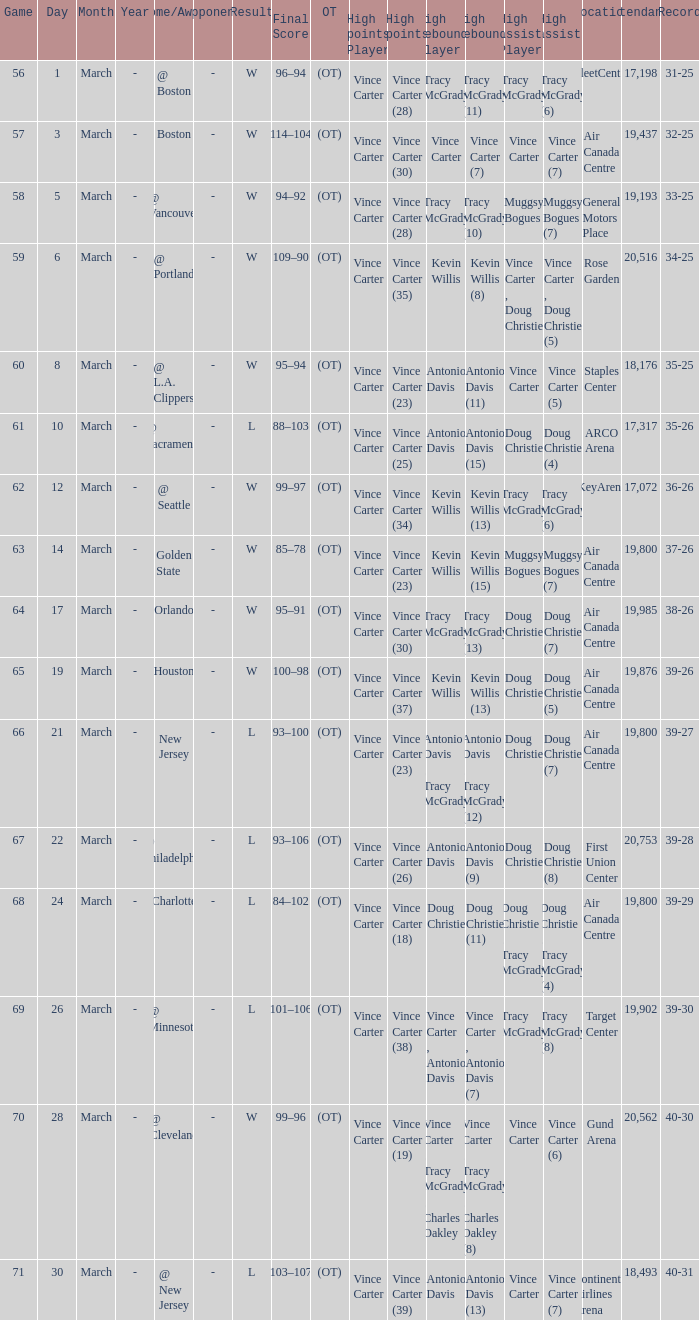Parse the table in full. {'header': ['Game', 'Day', 'Month', 'Year', 'Home/Away', 'Opponent', 'Result', 'Final Score', 'OT', 'High points Player', 'High points', 'High rebounds Player', 'High rebounds', 'High assists Player', 'High assists', 'Location', 'Attendance', 'Record'], 'rows': [['56', '1', 'March', '-', '@ Boston', '-', 'W', '96–94', '(OT)', 'Vince Carter', 'Vince Carter (28)', 'Tracy McGrady', 'Tracy McGrady (11)', 'Tracy McGrady', 'Tracy McGrady (6)', 'FleetCenter', '17,198', '31-25'], ['57', '3', 'March', '-', 'Boston', '-', 'W', '114–104', '(OT)', 'Vince Carter', 'Vince Carter (30)', 'Vince Carter', 'Vince Carter (7)', 'Vince Carter', 'Vince Carter (7)', 'Air Canada Centre', '19,437', '32-25'], ['58', '5', 'March', '-', '@ Vancouver', '-', 'W', '94–92', '(OT)', 'Vince Carter', 'Vince Carter (28)', 'Tracy McGrady', 'Tracy McGrady (10)', 'Muggsy Bogues', 'Muggsy Bogues (7)', 'General Motors Place', '19,193', '33-25'], ['59', '6', 'March', '-', '@ Portland', '-', 'W', '109–90', '(OT)', 'Vince Carter', 'Vince Carter (35)', 'Kevin Willis', 'Kevin Willis (8)', 'Vince Carter , Doug Christie', 'Vince Carter , Doug Christie (5)', 'Rose Garden', '20,516', '34-25'], ['60', '8', 'March', '-', '@ L.A. Clippers', '-', 'W', '95–94', '(OT)', 'Vince Carter', 'Vince Carter (23)', 'Antonio Davis', 'Antonio Davis (11)', 'Vince Carter', 'Vince Carter (5)', 'Staples Center', '18,176', '35-25'], ['61', '10', 'March', '-', '@ Sacramento', '-', 'L', '88–103', '(OT)', 'Vince Carter', 'Vince Carter (25)', 'Antonio Davis', 'Antonio Davis (15)', 'Doug Christie', 'Doug Christie (4)', 'ARCO Arena', '17,317', '35-26'], ['62', '12', 'March', '-', '@ Seattle', '-', 'W', '99–97', '(OT)', 'Vince Carter', 'Vince Carter (34)', 'Kevin Willis', 'Kevin Willis (13)', 'Tracy McGrady', 'Tracy McGrady (6)', 'KeyArena', '17,072', '36-26'], ['63', '14', 'March', '-', 'Golden State', '-', 'W', '85–78', '(OT)', 'Vince Carter', 'Vince Carter (23)', 'Kevin Willis', 'Kevin Willis (15)', 'Muggsy Bogues', 'Muggsy Bogues (7)', 'Air Canada Centre', '19,800', '37-26'], ['64', '17', 'March', '-', 'Orlando', '-', 'W', '95–91', '(OT)', 'Vince Carter', 'Vince Carter (30)', 'Tracy McGrady', 'Tracy McGrady (13)', 'Doug Christie', 'Doug Christie (7)', 'Air Canada Centre', '19,985', '38-26'], ['65', '19', 'March', '-', 'Houston', '-', 'W', '100–98', '(OT)', 'Vince Carter', 'Vince Carter (37)', 'Kevin Willis', 'Kevin Willis (13)', 'Doug Christie', 'Doug Christie (5)', 'Air Canada Centre', '19,876', '39-26'], ['66', '21', 'March', '-', 'New Jersey', '-', 'L', '93–100', '(OT)', 'Vince Carter', 'Vince Carter (23)', 'Antonio Davis , Tracy McGrady', 'Antonio Davis , Tracy McGrady (12)', 'Doug Christie', 'Doug Christie (7)', 'Air Canada Centre', '19,800', '39-27'], ['67', '22', 'March', '-', '@ Philadelphia', '-', 'L', '93–106', '(OT)', 'Vince Carter', 'Vince Carter (26)', 'Antonio Davis', 'Antonio Davis (9)', 'Doug Christie', 'Doug Christie (8)', 'First Union Center', '20,753', '39-28'], ['68', '24', 'March', '-', 'Charlotte', '-', 'L', '84–102', '(OT)', 'Vince Carter', 'Vince Carter (18)', 'Doug Christie', 'Doug Christie (11)', 'Doug Christie , Tracy McGrady', 'Doug Christie , Tracy McGrady (4)', 'Air Canada Centre', '19,800', '39-29'], ['69', '26', 'March', '-', '@ Minnesota', '-', 'L', '101–106', '(OT)', 'Vince Carter', 'Vince Carter (38)', 'Vince Carter , Antonio Davis', 'Vince Carter , Antonio Davis (7)', 'Tracy McGrady', 'Tracy McGrady (8)', 'Target Center', '19,902', '39-30'], ['70', '28', 'March', '-', '@ Cleveland', '-', 'W', '99–96', '(OT)', 'Vince Carter', 'Vince Carter (19)', 'Vince Carter , Tracy McGrady , Charles Oakley', 'Vince Carter , Tracy McGrady , Charles Oakley (8)', 'Vince Carter', 'Vince Carter (6)', 'Gund Arena', '20,562', '40-30'], ['71', '30', 'March', '-', '@ New Jersey', '-', 'L', '103–107', '(OT)', 'Vince Carter', 'Vince Carter (39)', 'Antonio Davis', 'Antonio Davis (13)', 'Vince Carter', 'Vince Carter (7)', 'Continental Airlines Arena', '18,493', '40-31']]} What day was the attendance at the staples center 18,176? March 8. 